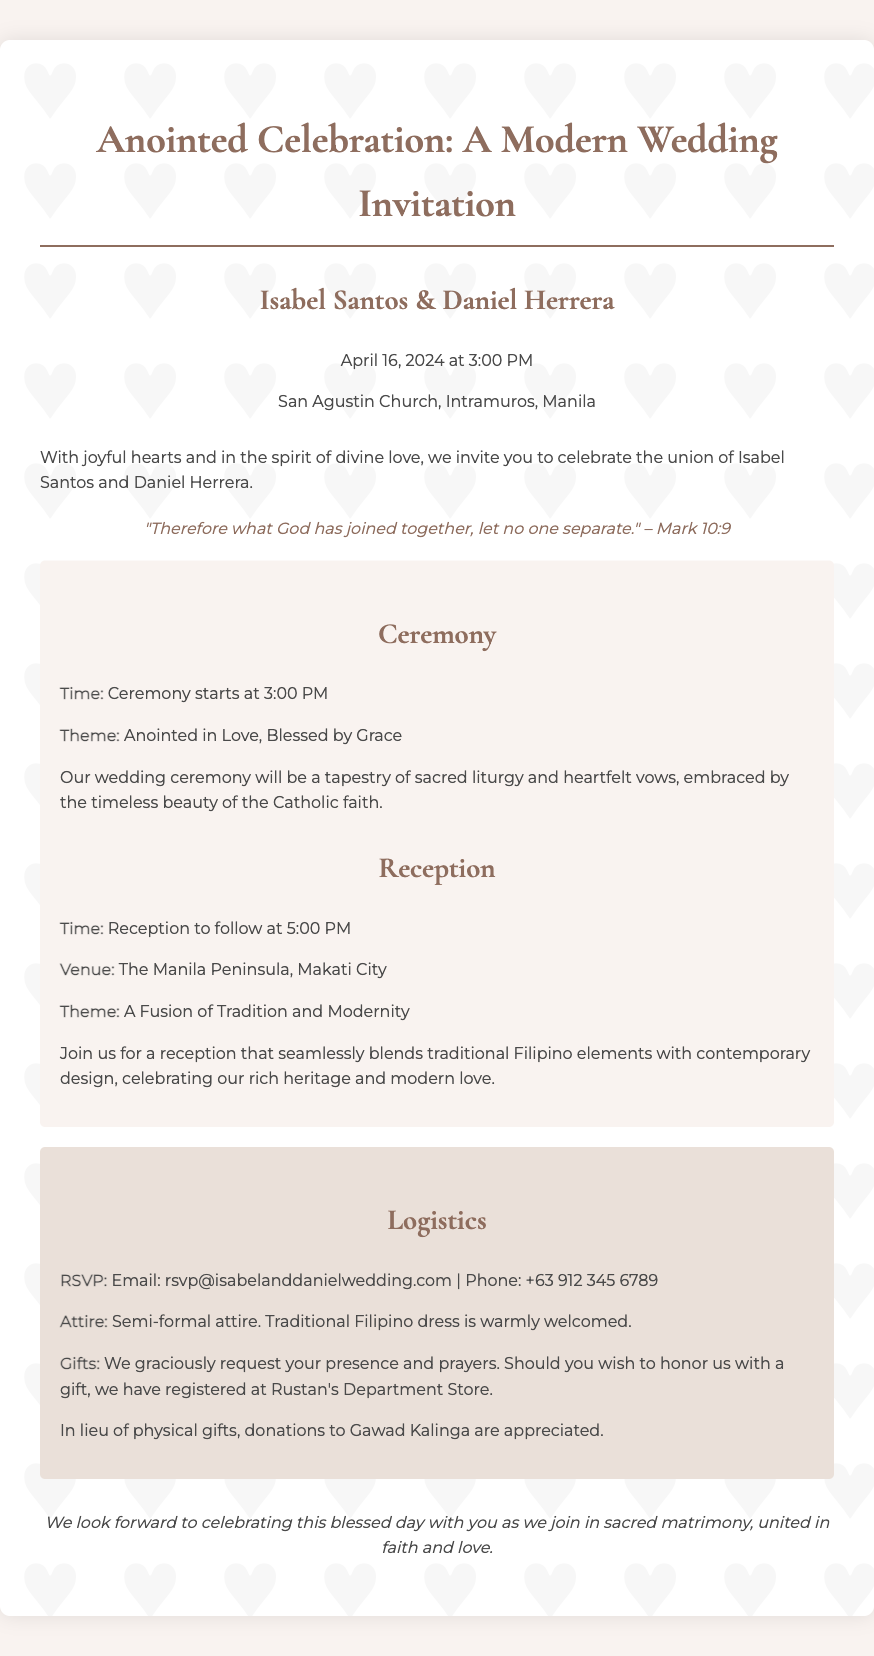What is the date of the wedding? The date of the wedding is explicitly mentioned in the invitation text, which states "April 16, 2024."
Answer: April 16, 2024 What is the theme of the wedding ceremony? The invitation lists the ceremony theme as "Anointed in Love, Blessed by Grace."
Answer: Anointed in Love, Blessed by Grace Where will the reception take place? The venue for the reception is mentioned in the logistics section, specifying "The Manila Peninsula, Makati City."
Answer: The Manila Peninsula, Makati City What is the RSVP email address? The document provides the RSVP contact information, stating "Email: rsvp@isabelanddanielwedding.com."
Answer: rsvp@isabelanddanielwedding.com What scripture verse is included in the invitation? The invitation features a specific verse, which is "Therefore what God has joined together, let no one separate." – Mark 10:9.
Answer: Therefore what God has joined together, let no one separate 